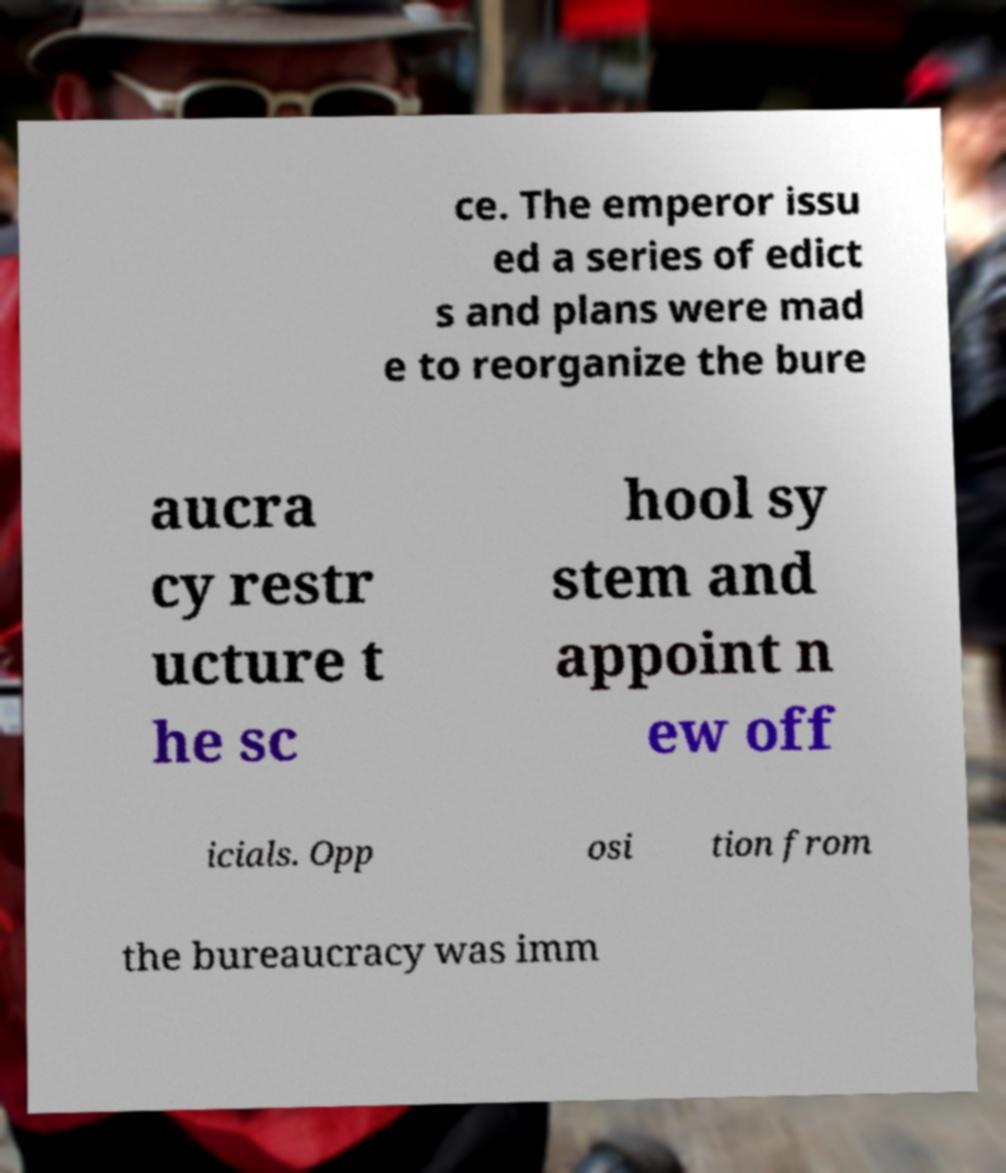Please identify and transcribe the text found in this image. ce. The emperor issu ed a series of edict s and plans were mad e to reorganize the bure aucra cy restr ucture t he sc hool sy stem and appoint n ew off icials. Opp osi tion from the bureaucracy was imm 